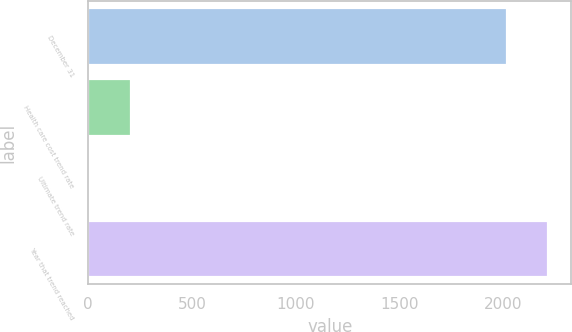Convert chart. <chart><loc_0><loc_0><loc_500><loc_500><bar_chart><fcel>December 31<fcel>Health care cost trend rate<fcel>Ultimate trend rate<fcel>Year that trend reached<nl><fcel>2017<fcel>206.15<fcel>4.5<fcel>2218.65<nl></chart> 